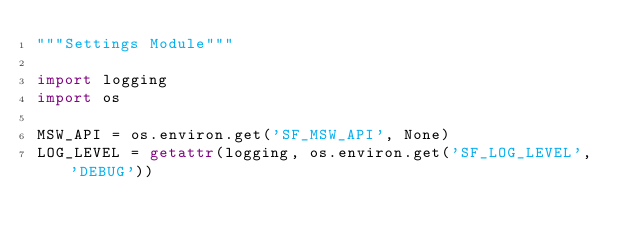Convert code to text. <code><loc_0><loc_0><loc_500><loc_500><_Python_>"""Settings Module"""

import logging
import os

MSW_API = os.environ.get('SF_MSW_API', None)
LOG_LEVEL = getattr(logging, os.environ.get('SF_LOG_LEVEL', 'DEBUG'))
</code> 